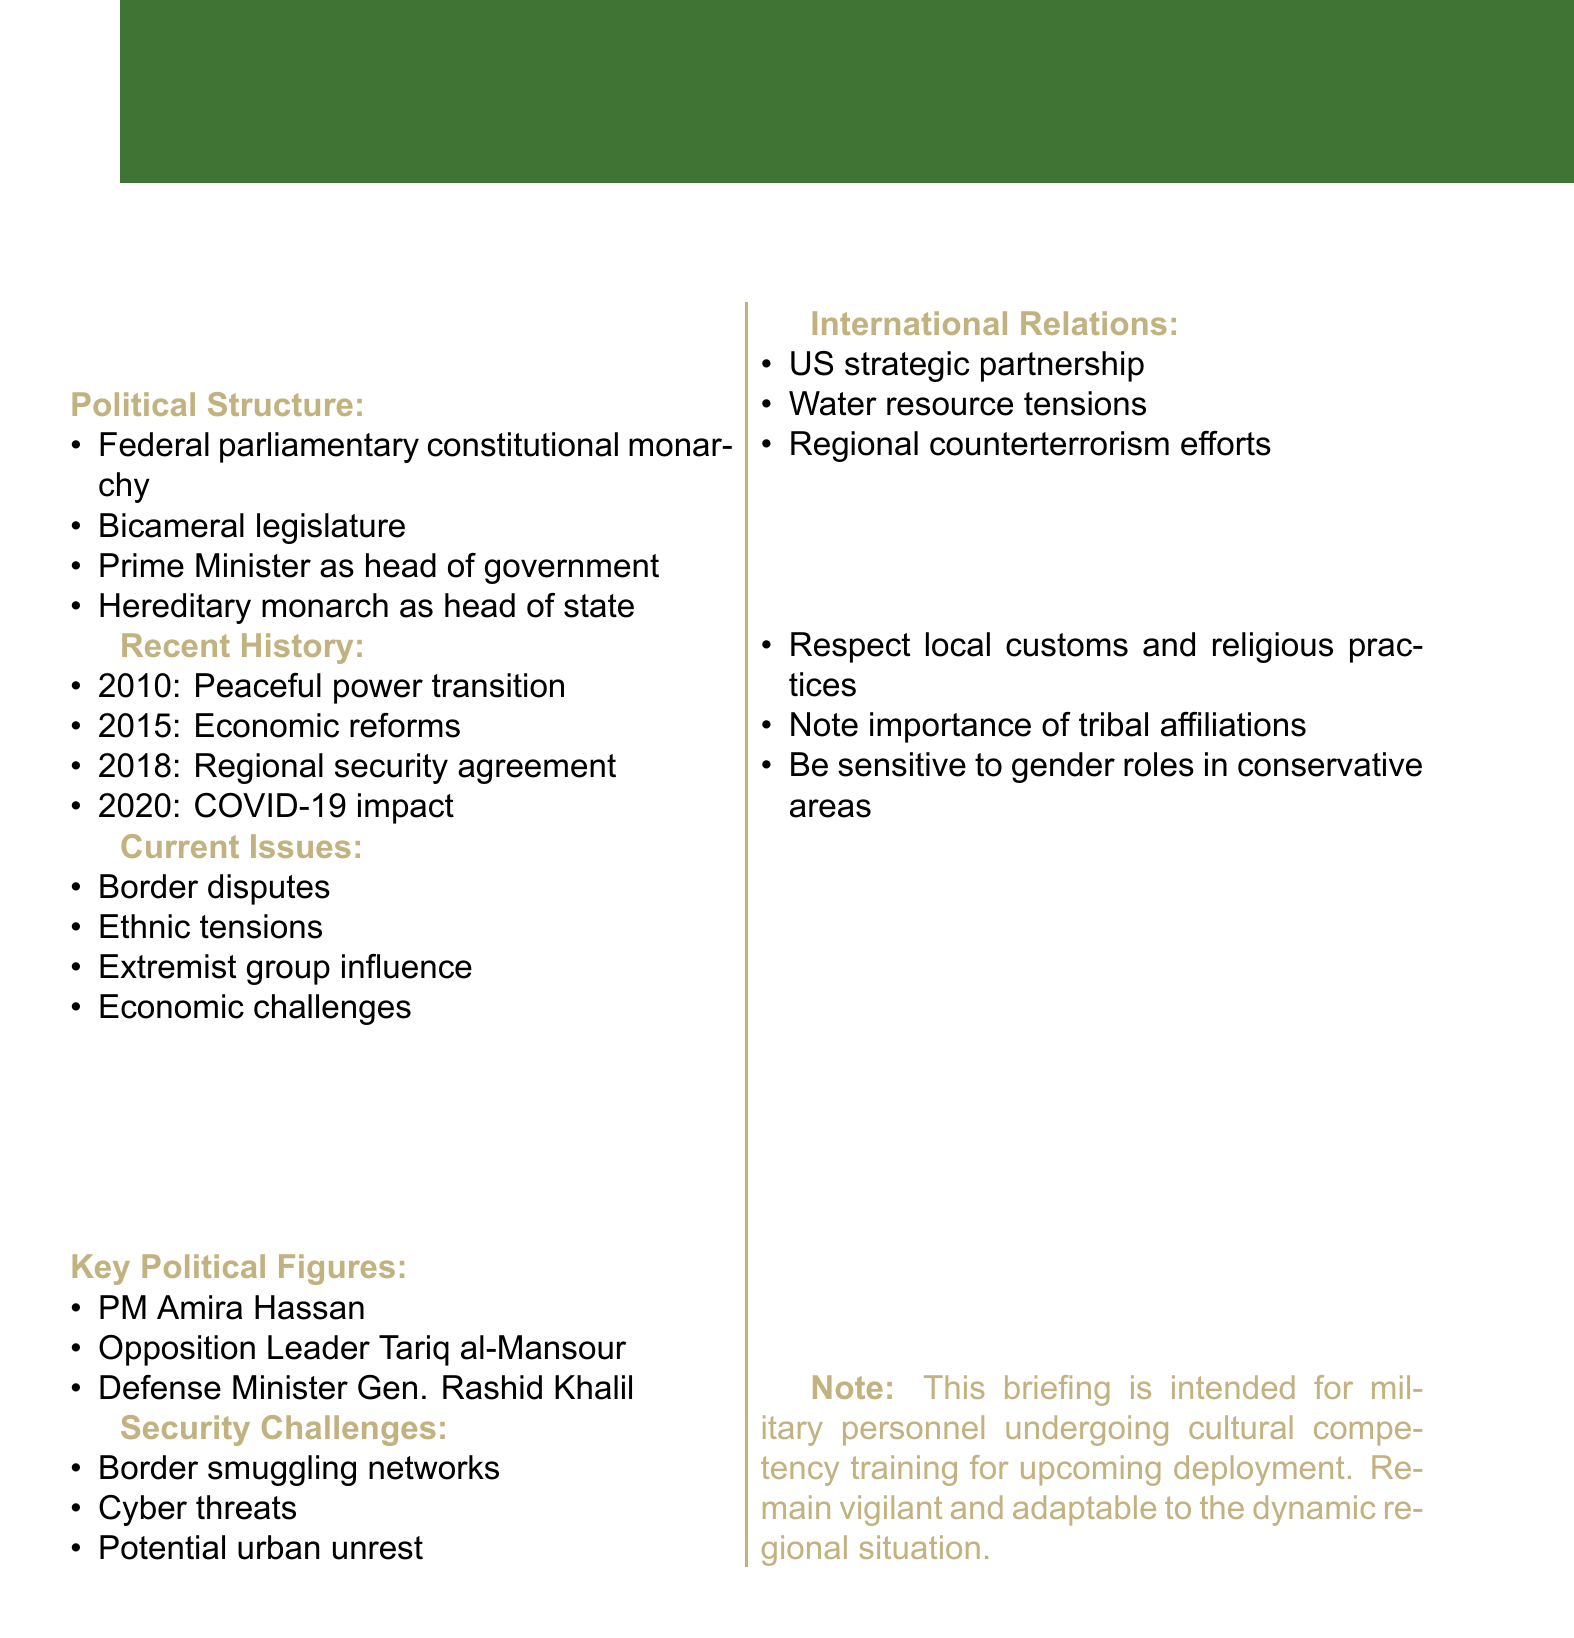What is the political structure of the region? The political structure is a Federal parliamentary constitutional monarchy, as stated in the document.
Answer: Federal parliamentary constitutional monarchy Who is the current Prime Minister? The document lists key political figures, including the current Prime Minister.
Answer: Amira Hassan What significant event happened in 2010? The document outlines recent history, indicating that 2010 saw a peaceful transition of power.
Answer: Peaceful transition of power What are the main security challenges mentioned? The document specifies several security challenges relevant to the mission in the region.
Answer: Smuggling networks along porous borders What is a current issue affecting the mission? The document lists several ongoing issues; one is particularly relevant to the mission context.
Answer: Ongoing border disputes with neighboring country Which two key political figures are mentioned? The document highlights key political figures that are relevant to understanding the political landscape.
Answer: Amira Hassan, Tariq al-Mansour What key international relationship is established? The document discusses international relations, indicating a strategic partnership.
Answer: Strategic partnership with United States During what year was the regional security cooperation agreement signed? The year associated with the signing of a regional cooperation agreement is included in the recent history section.
Answer: 2018 What cultural consideration is emphasized in the document? The document stresses the importance of adapting to local customs and practices for effective engagement.
Answer: Respect for local customs and religious practices 